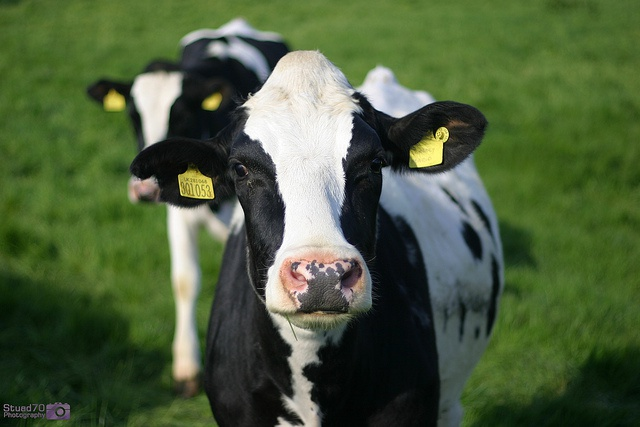Describe the objects in this image and their specific colors. I can see cow in darkgreen, black, white, gray, and darkgray tones and cow in darkgreen, black, lightgray, darkgray, and gray tones in this image. 